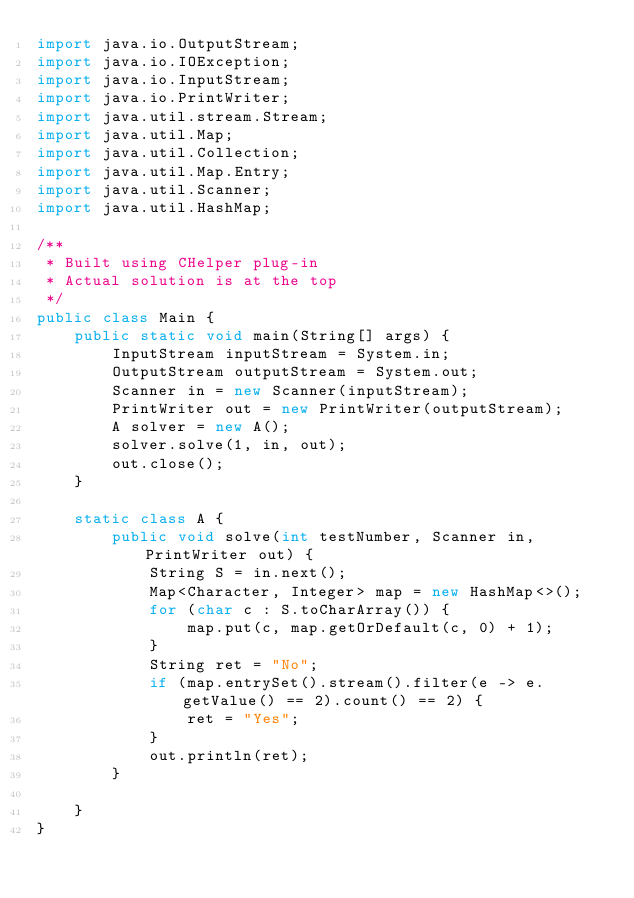Convert code to text. <code><loc_0><loc_0><loc_500><loc_500><_Java_>import java.io.OutputStream;
import java.io.IOException;
import java.io.InputStream;
import java.io.PrintWriter;
import java.util.stream.Stream;
import java.util.Map;
import java.util.Collection;
import java.util.Map.Entry;
import java.util.Scanner;
import java.util.HashMap;

/**
 * Built using CHelper plug-in
 * Actual solution is at the top
 */
public class Main {
    public static void main(String[] args) {
        InputStream inputStream = System.in;
        OutputStream outputStream = System.out;
        Scanner in = new Scanner(inputStream);
        PrintWriter out = new PrintWriter(outputStream);
        A solver = new A();
        solver.solve(1, in, out);
        out.close();
    }

    static class A {
        public void solve(int testNumber, Scanner in, PrintWriter out) {
            String S = in.next();
            Map<Character, Integer> map = new HashMap<>();
            for (char c : S.toCharArray()) {
                map.put(c, map.getOrDefault(c, 0) + 1);
            }
            String ret = "No";
            if (map.entrySet().stream().filter(e -> e.getValue() == 2).count() == 2) {
                ret = "Yes";
            }
            out.println(ret);
        }

    }
}

</code> 